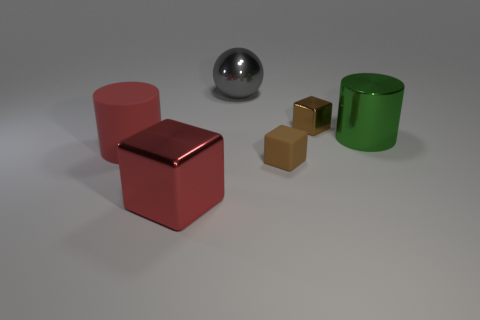What number of other green objects are the same shape as the big rubber object?
Ensure brevity in your answer.  1. There is a small thing that is the same color as the small shiny block; what is it made of?
Your answer should be very brief. Rubber. Is there anything else that is the same shape as the large gray metallic thing?
Your answer should be compact. No. There is a metallic block to the right of the tiny thing that is in front of the big thing that is to the right of the metal ball; what is its color?
Offer a very short reply. Brown. What number of tiny objects are either purple things or brown rubber cubes?
Offer a very short reply. 1. Is the number of cubes that are behind the big rubber object the same as the number of big gray shiny balls?
Ensure brevity in your answer.  Yes. There is a red matte thing; are there any small brown matte things right of it?
Your response must be concise. Yes. What number of rubber objects are gray objects or green things?
Offer a terse response. 0. What number of red blocks are to the left of the gray metallic thing?
Offer a very short reply. 1. Is there a rubber sphere that has the same size as the red cylinder?
Offer a very short reply. No. 